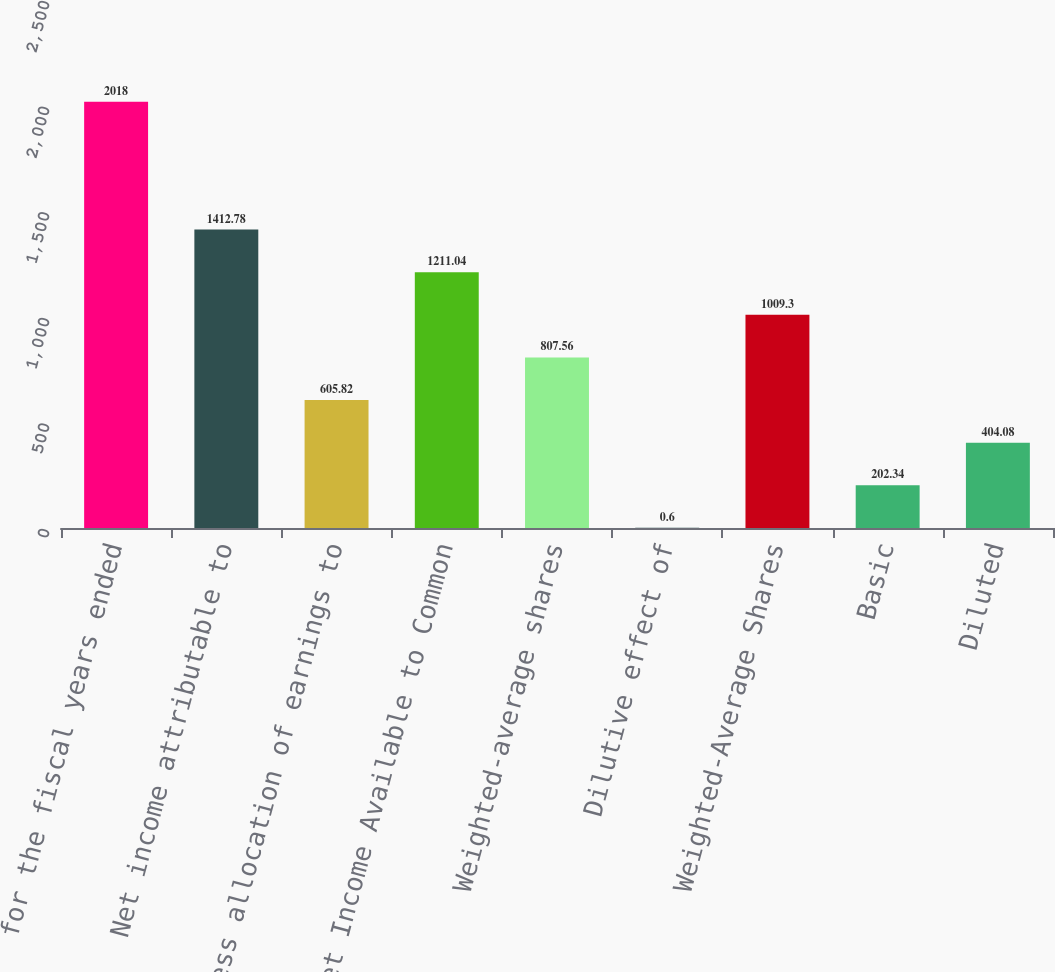Convert chart. <chart><loc_0><loc_0><loc_500><loc_500><bar_chart><fcel>for the fiscal years ended<fcel>Net income attributable to<fcel>Less allocation of earnings to<fcel>Net Income Available to Common<fcel>Weighted-average shares<fcel>Dilutive effect of<fcel>Weighted-Average Shares<fcel>Basic<fcel>Diluted<nl><fcel>2018<fcel>1412.78<fcel>605.82<fcel>1211.04<fcel>807.56<fcel>0.6<fcel>1009.3<fcel>202.34<fcel>404.08<nl></chart> 